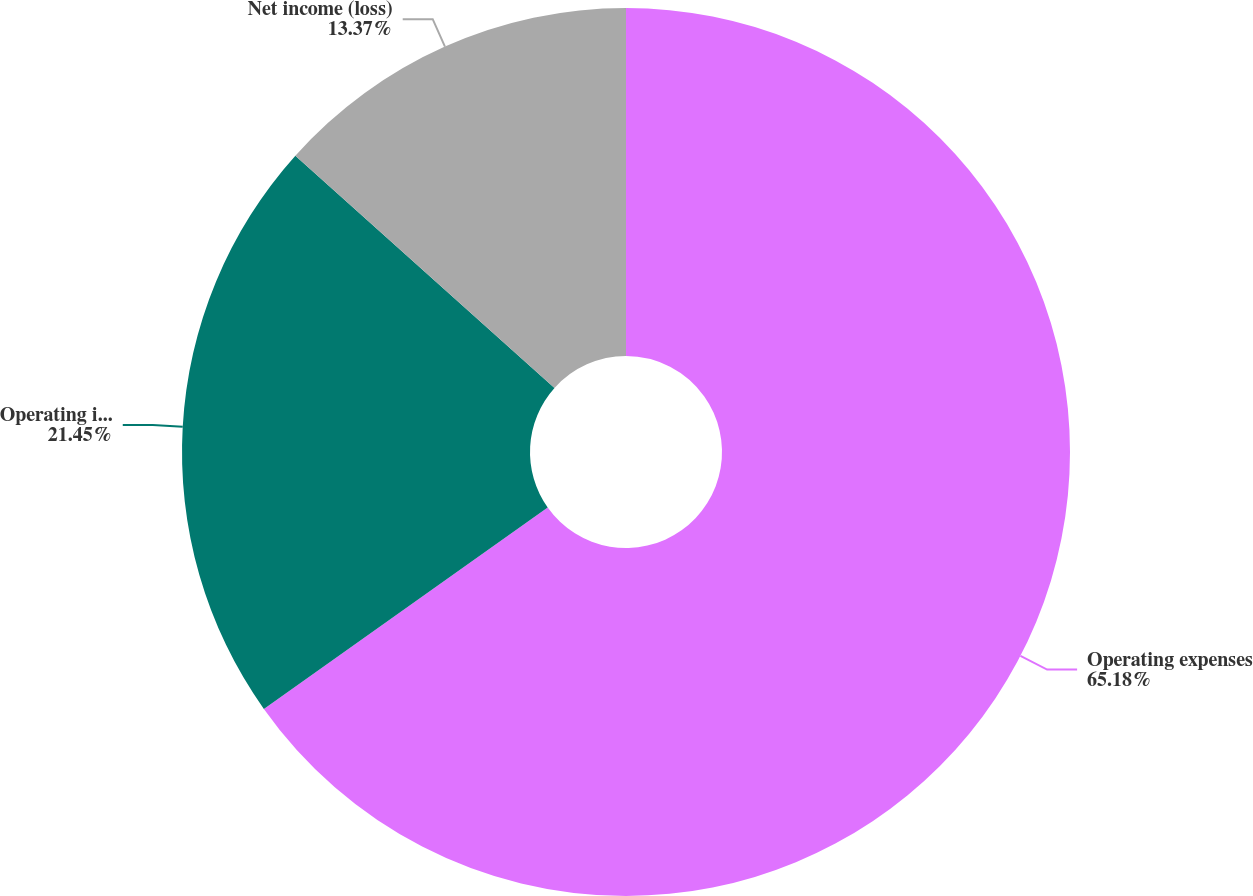<chart> <loc_0><loc_0><loc_500><loc_500><pie_chart><fcel>Operating expenses<fcel>Operating income (loss)<fcel>Net income (loss)<nl><fcel>65.18%<fcel>21.45%<fcel>13.37%<nl></chart> 